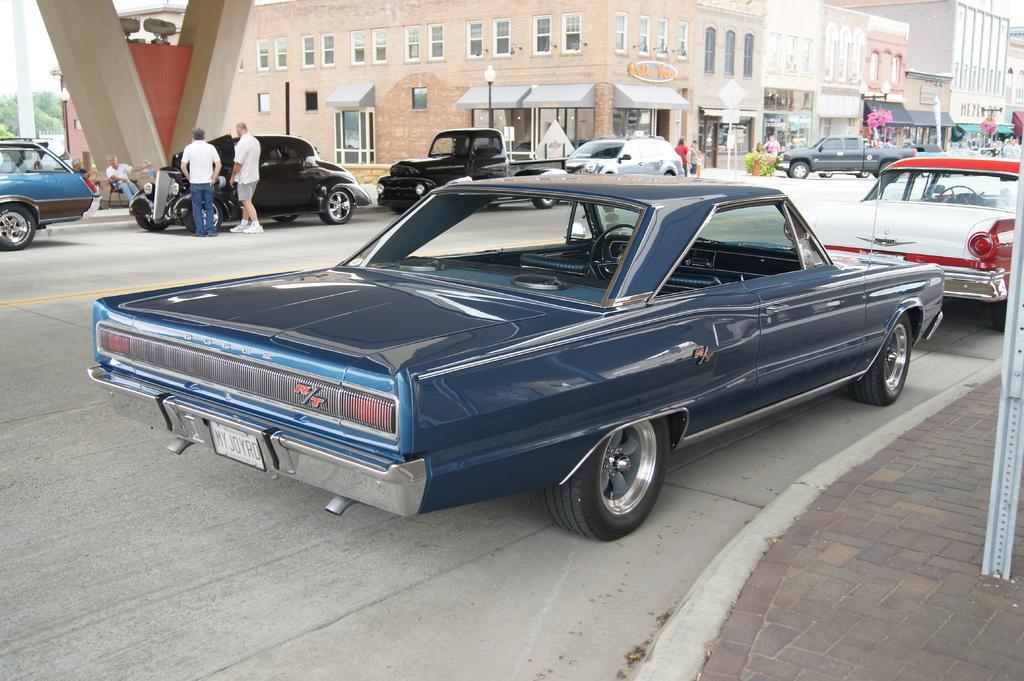How would you summarize this image in a sentence or two? In this picture we can see vehicles and people on the road. Behind the vehicles, there are street lights and there are buildings with windows and doors. On the left side of the image, a few people are sitting on the chairs. Behind the people, there are trees, a pole and the sky. On the right side of the image, there is another pole. 